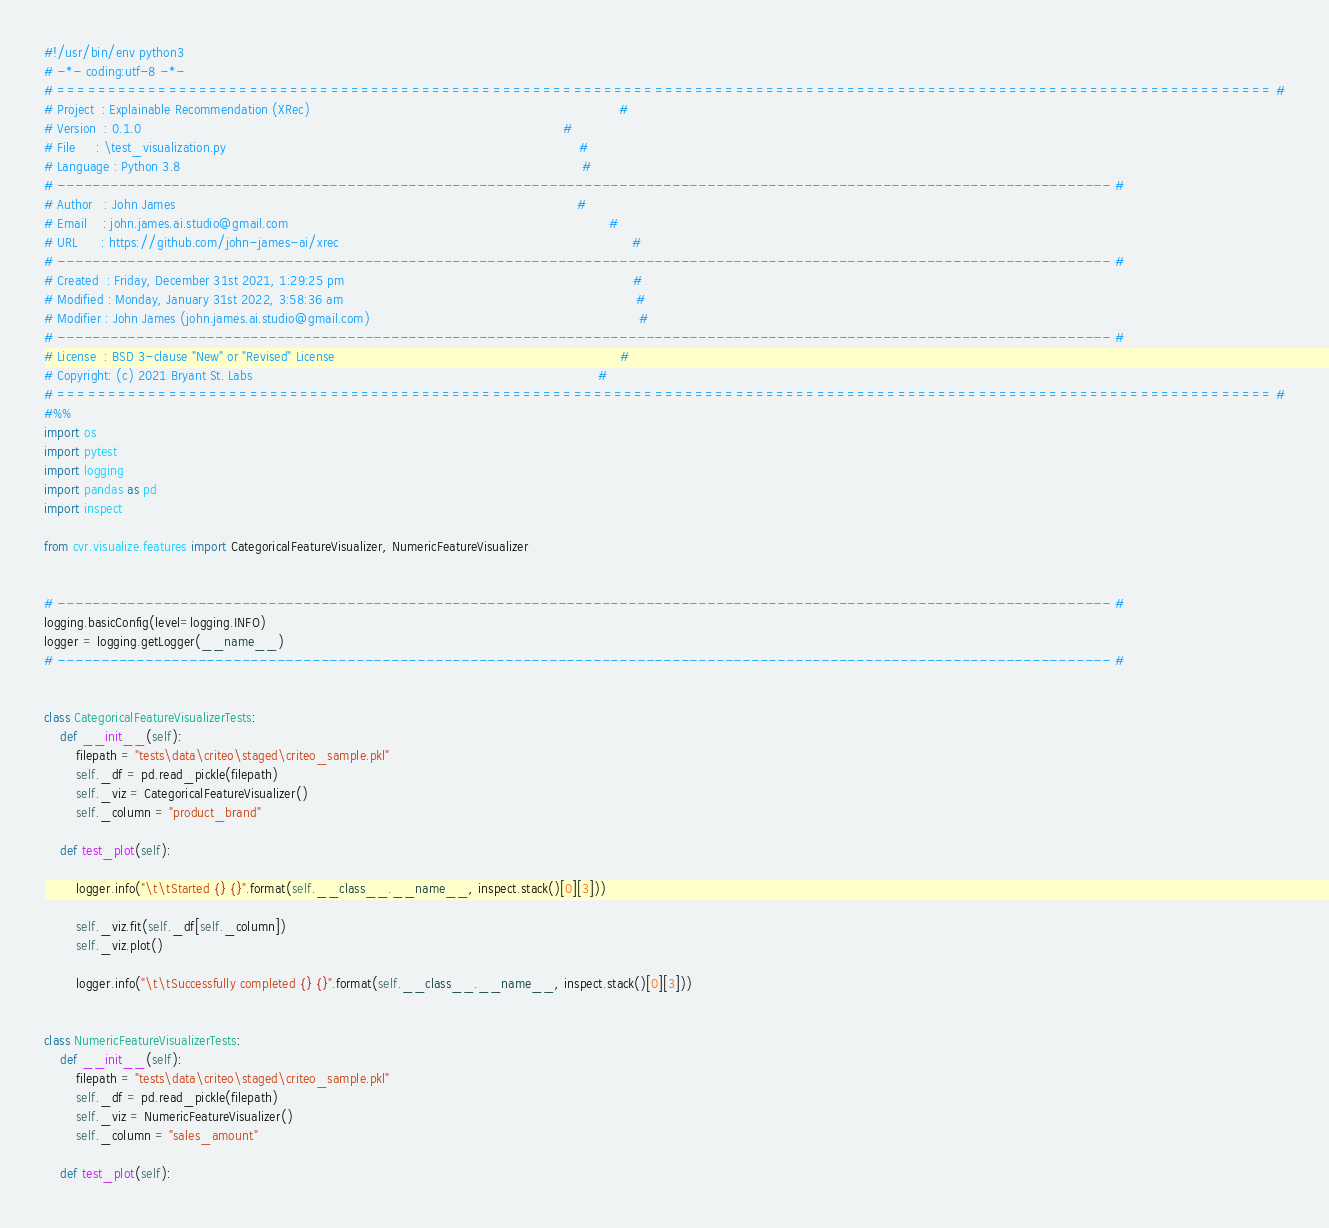Convert code to text. <code><loc_0><loc_0><loc_500><loc_500><_Python_>#!/usr/bin/env python3
# -*- coding:utf-8 -*-
# ======================================================================================================================== #
# Project  : Explainable Recommendation (XRec)                                                                             #
# Version  : 0.1.0                                                                                                         #
# File     : \test_visualization.py                                                                                        #
# Language : Python 3.8                                                                                                    #
# ------------------------------------------------------------------------------------------------------------------------ #
# Author   : John James                                                                                                    #
# Email    : john.james.ai.studio@gmail.com                                                                                #
# URL      : https://github.com/john-james-ai/xrec                                                                         #
# ------------------------------------------------------------------------------------------------------------------------ #
# Created  : Friday, December 31st 2021, 1:29:25 pm                                                                        #
# Modified : Monday, January 31st 2022, 3:58:36 am                                                                         #
# Modifier : John James (john.james.ai.studio@gmail.com)                                                                   #
# ------------------------------------------------------------------------------------------------------------------------ #
# License  : BSD 3-clause "New" or "Revised" License                                                                       #
# Copyright: (c) 2021 Bryant St. Labs                                                                                      #
# ======================================================================================================================== #
#%%
import os
import pytest
import logging
import pandas as pd
import inspect

from cvr.visualize.features import CategoricalFeatureVisualizer, NumericFeatureVisualizer


# ------------------------------------------------------------------------------------------------------------------------ #
logging.basicConfig(level=logging.INFO)
logger = logging.getLogger(__name__)
# ------------------------------------------------------------------------------------------------------------------------ #


class CategoricalFeatureVisualizerTests:
    def __init__(self):
        filepath = "tests\data\criteo\staged\criteo_sample.pkl"
        self._df = pd.read_pickle(filepath)
        self._viz = CategoricalFeatureVisualizer()
        self._column = "product_brand"

    def test_plot(self):

        logger.info("\t\tStarted {} {}".format(self.__class__.__name__, inspect.stack()[0][3]))

        self._viz.fit(self._df[self._column])
        self._viz.plot()

        logger.info("\t\tSuccessfully completed {} {}".format(self.__class__.__name__, inspect.stack()[0][3]))


class NumericFeatureVisualizerTests:
    def __init__(self):
        filepath = "tests\data\criteo\staged\criteo_sample.pkl"
        self._df = pd.read_pickle(filepath)
        self._viz = NumericFeatureVisualizer()
        self._column = "sales_amount"

    def test_plot(self):
</code> 